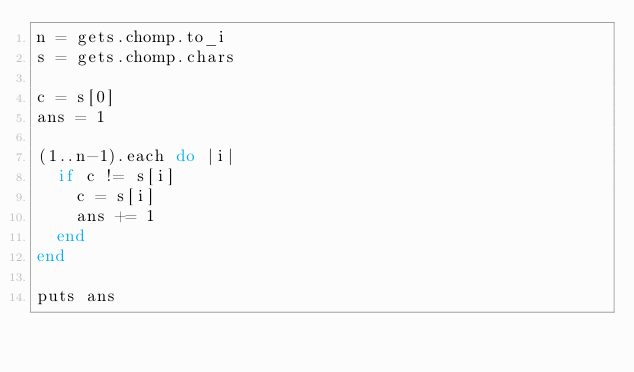Convert code to text. <code><loc_0><loc_0><loc_500><loc_500><_Ruby_>n = gets.chomp.to_i
s = gets.chomp.chars

c = s[0]
ans = 1

(1..n-1).each do |i|
  if c != s[i]
    c = s[i]
    ans += 1
  end
end

puts ans</code> 